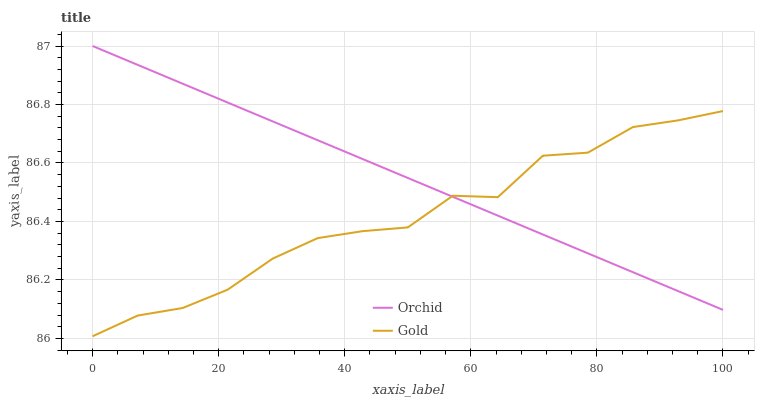Does Orchid have the minimum area under the curve?
Answer yes or no. No. Is Orchid the roughest?
Answer yes or no. No. Does Orchid have the lowest value?
Answer yes or no. No. 